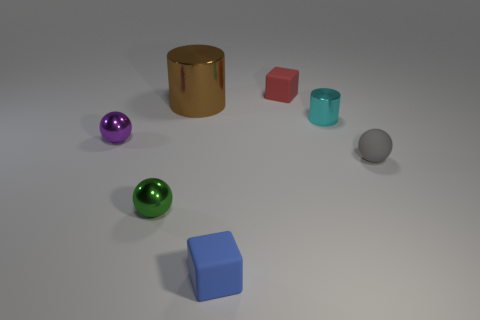How many big brown rubber objects are there?
Make the answer very short. 0. Are there any small spheres in front of the small gray rubber ball?
Offer a terse response. Yes. Do the small sphere that is behind the tiny gray matte sphere and the small ball to the right of the green object have the same material?
Give a very brief answer. No. Are there fewer small metal things that are on the right side of the brown metal cylinder than red cubes?
Make the answer very short. No. What color is the ball that is on the right side of the large brown thing?
Make the answer very short. Gray. There is a cylinder that is left of the rubber block that is behind the small green metal ball; what is its material?
Make the answer very short. Metal. Is there a gray matte thing of the same size as the cyan object?
Ensure brevity in your answer.  Yes. What number of things are either small matte objects that are on the right side of the tiny blue rubber object or tiny shiny things on the right side of the green metal thing?
Make the answer very short. 3. There is a object behind the large metallic cylinder; is it the same size as the metallic cylinder that is left of the tiny red block?
Keep it short and to the point. No. Are there any small matte objects right of the rubber block that is in front of the red rubber cube?
Offer a very short reply. Yes. 